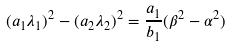Convert formula to latex. <formula><loc_0><loc_0><loc_500><loc_500>( a _ { 1 } \lambda _ { 1 } ) ^ { 2 } - ( a _ { 2 } \lambda _ { 2 } ) ^ { 2 } = \frac { a _ { 1 } } { b _ { 1 } } ( \beta ^ { 2 } - \alpha ^ { 2 } )</formula> 